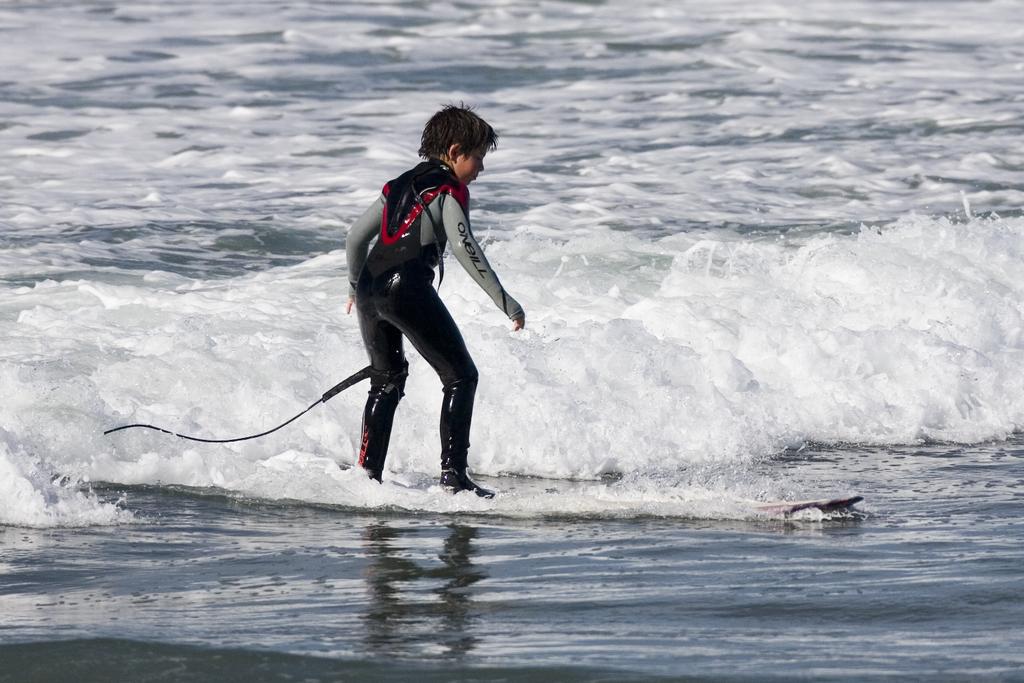What brand is on his sleeve?
Your response must be concise. O'neill. 